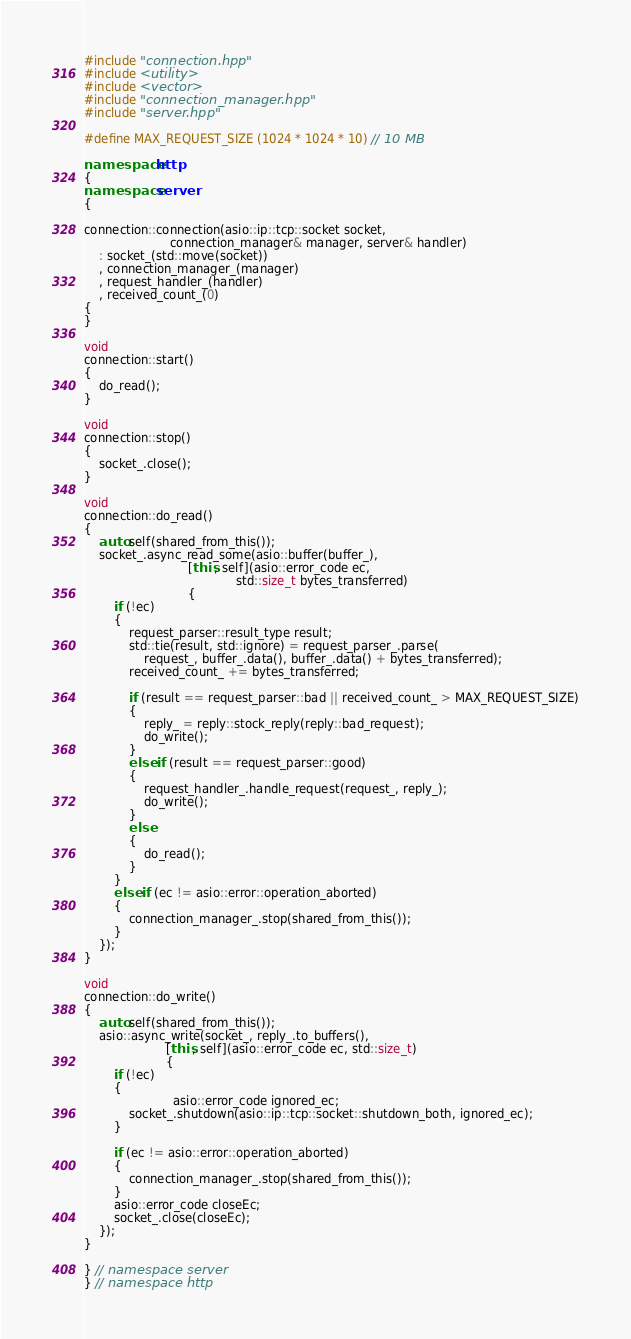<code> <loc_0><loc_0><loc_500><loc_500><_C++_>
#include "connection.hpp"
#include <utility>
#include <vector>
#include "connection_manager.hpp"
#include "server.hpp"

#define MAX_REQUEST_SIZE (1024 * 1024 * 10) // 10 MB

namespace http
{
namespace server
{

connection::connection(asio::ip::tcp::socket socket,
                       connection_manager& manager, server& handler)
    : socket_(std::move(socket))
    , connection_manager_(manager)
    , request_handler_(handler)
    , received_count_(0)
{
}

void
connection::start()
{
    do_read();
}

void
connection::stop()
{
    socket_.close();
}

void
connection::do_read()
{
    auto self(shared_from_this());
    socket_.async_read_some(asio::buffer(buffer_),
                            [this, self](asio::error_code ec,
                                         std::size_t bytes_transferred)
                            {
        if (!ec)
        {
            request_parser::result_type result;
            std::tie(result, std::ignore) = request_parser_.parse(
                request_, buffer_.data(), buffer_.data() + bytes_transferred);
            received_count_ += bytes_transferred;

            if (result == request_parser::bad || received_count_ > MAX_REQUEST_SIZE)
            {
                reply_ = reply::stock_reply(reply::bad_request);
                do_write();
            }
            else if (result == request_parser::good)
            {
                request_handler_.handle_request(request_, reply_);
                do_write();
            }
            else
            {
                do_read();
            }
        }
        else if (ec != asio::error::operation_aborted)
        {
            connection_manager_.stop(shared_from_this());
        }
    });
}

void
connection::do_write()
{
    auto self(shared_from_this());
    asio::async_write(socket_, reply_.to_buffers(),
                      [this, self](asio::error_code ec, std::size_t)
                      {
        if (!ec)
        {
                        asio::error_code ignored_ec;
            socket_.shutdown(asio::ip::tcp::socket::shutdown_both, ignored_ec);
        }

        if (ec != asio::error::operation_aborted)
        {
            connection_manager_.stop(shared_from_this());
        }
        asio::error_code closeEc;
        socket_.close(closeEc);
    });
}

} // namespace server
} // namespace http
</code> 